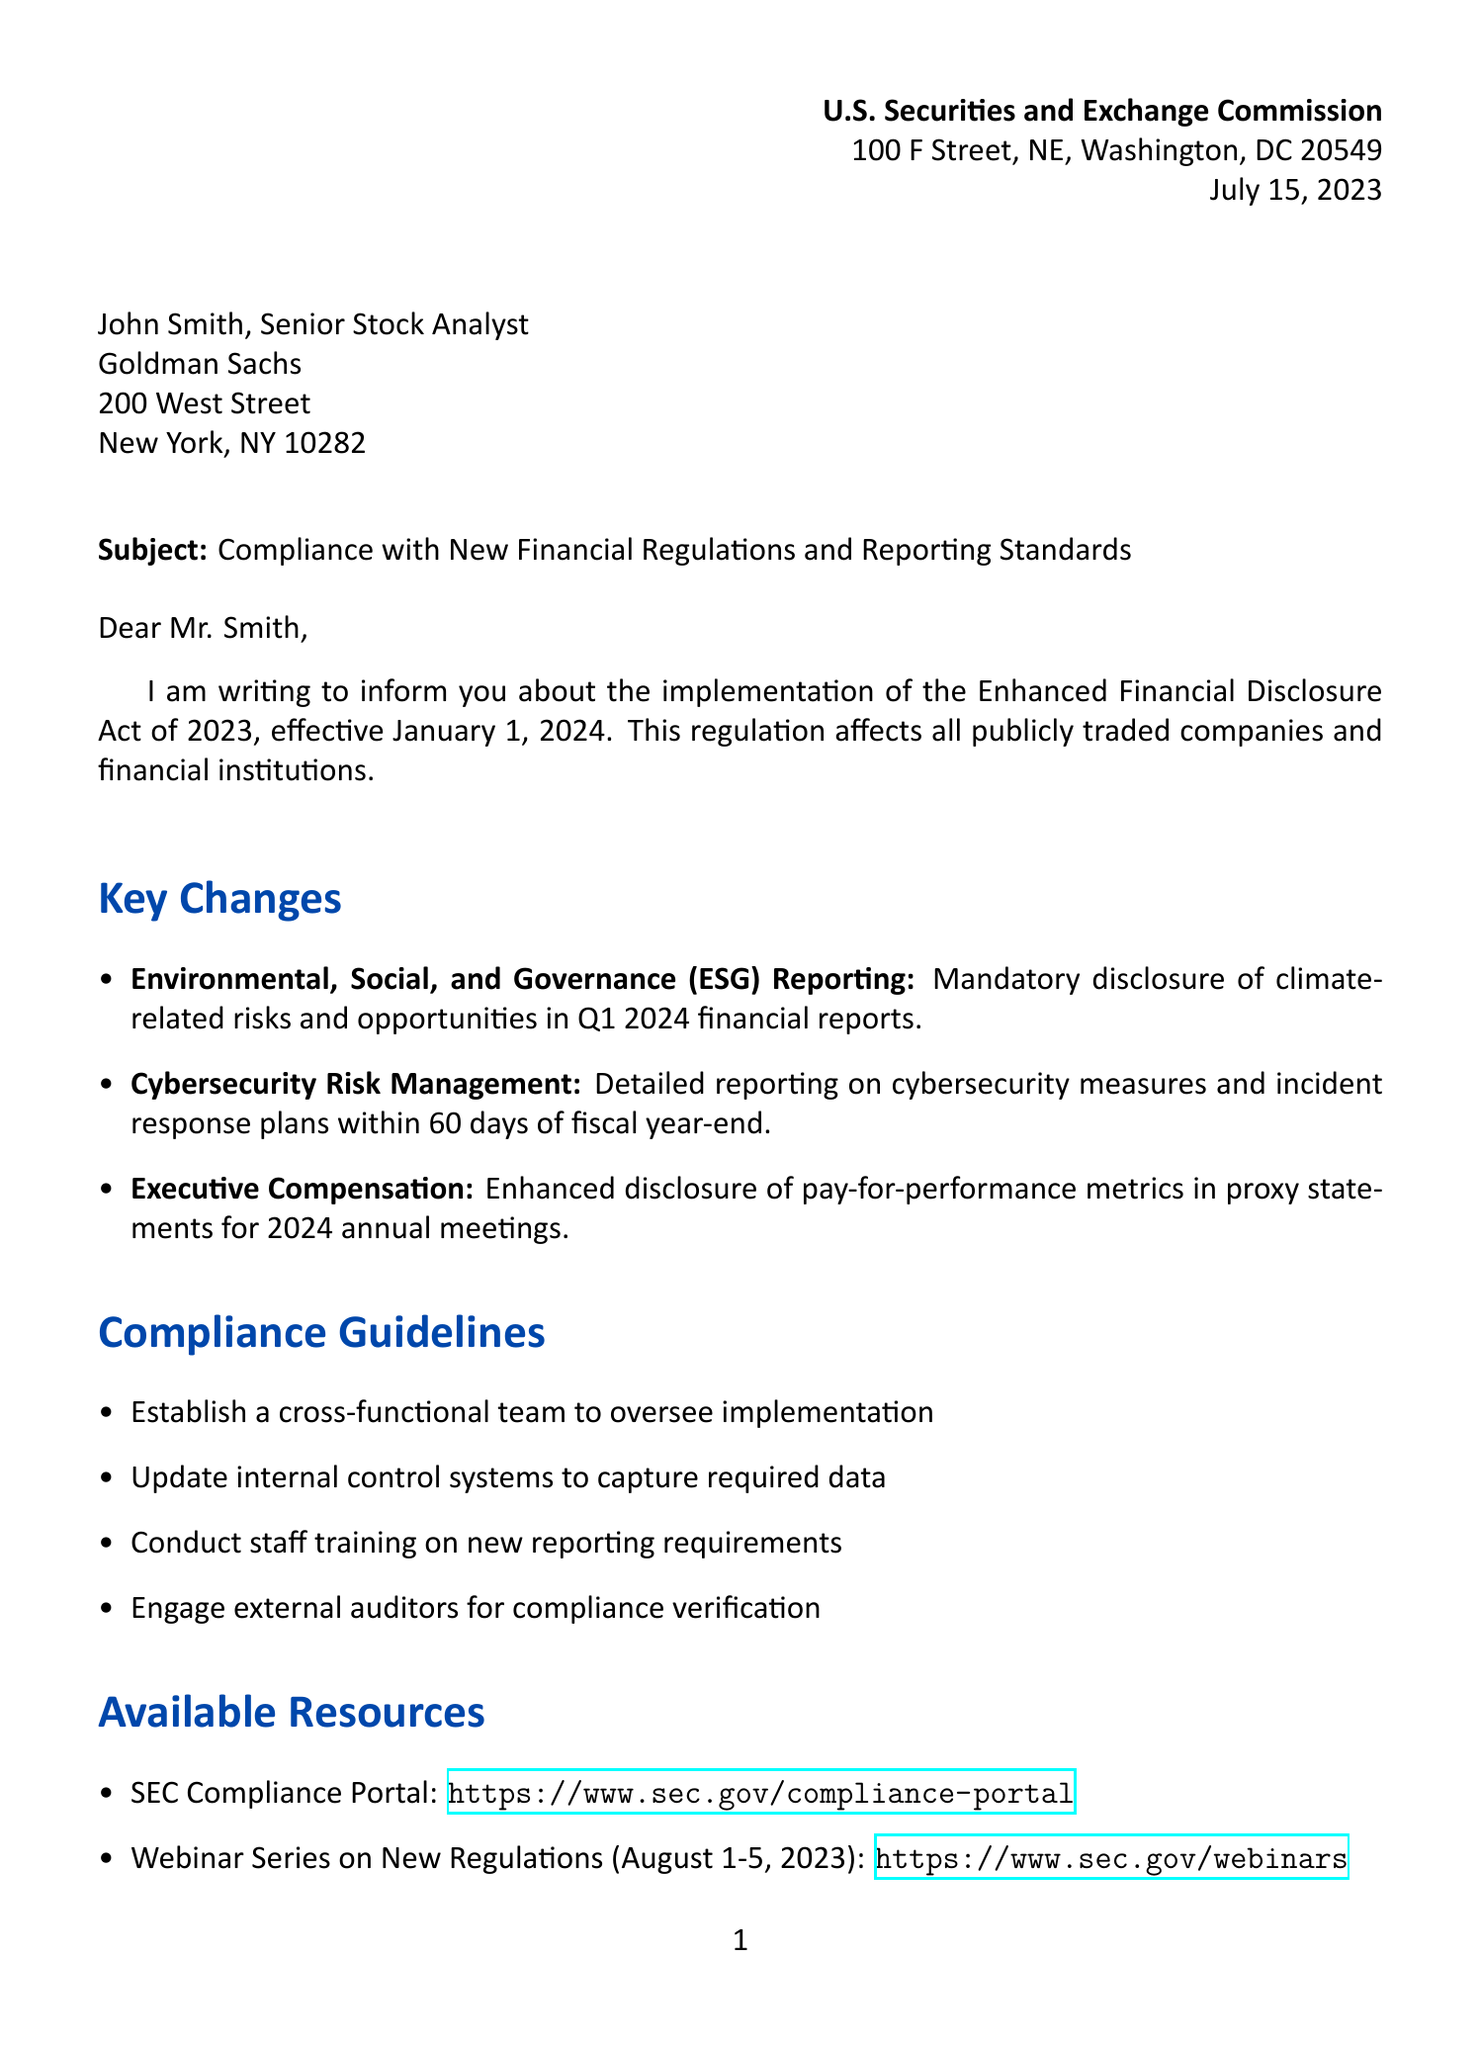What is the regulation name mentioned in the letter? The regulation name is specified in the introduction section of the letter as "Enhanced Financial Disclosure Act of 2023".
Answer: Enhanced Financial Disclosure Act of 2023 When will the new regulations take effect? The implementation date for the new regulations is stated in the introduction section of the letter.
Answer: January 1, 2024 What is the deadline for ESG reporting? The deadline for ESG reporting is mentioned in the key changes section regarding Environmental, Social, and Governance (ESG) Reporting.
Answer: Q1 2024 financial reports Who should be contacted for further assistance? The contact information section of the letter lists a specific department for further assistance.
Answer: Office of Compliance Inspections and Examinations What penalty is specified for serious violations? The letter mentions specific penalties for non-compliance, including a fine amount.
Answer: Up to $10 million What is emphasized as crucial for market integrity? The closing remarks section highlights what is essential for maintaining market integrity.
Answer: Timely compliance What are the dates for the Webinar Series on New Regulations? The letter includes specific dates for the Webinar Series under the available resources section.
Answer: August 1-5, 2023 What is one compliance guideline recommended in the letter? The compliance guidelines section provides several recommendations; one example is mentioned directly.
Answer: Establish a cross-functional team to oversee implementation What is the title of the person who signed the letter? The signature section identifies the title of Gary Gensler, who signed the letter.
Answer: Chair, U.S. Securities and Exchange Commission 